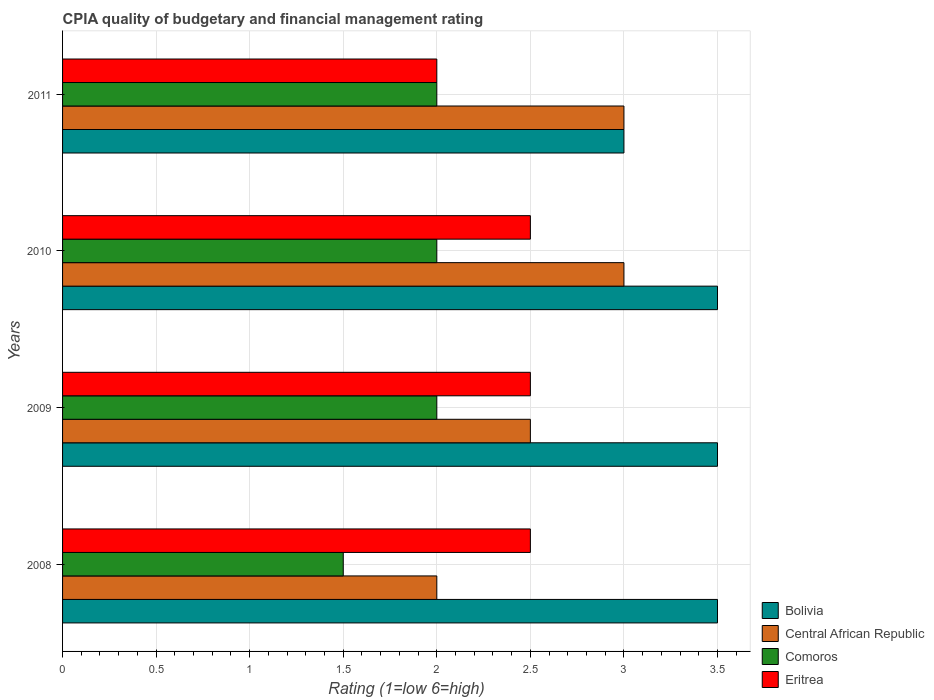How many different coloured bars are there?
Ensure brevity in your answer.  4. Are the number of bars on each tick of the Y-axis equal?
Offer a terse response. Yes. How many bars are there on the 4th tick from the top?
Your answer should be very brief. 4. What is the CPIA rating in Comoros in 2011?
Provide a succinct answer. 2. Across all years, what is the minimum CPIA rating in Eritrea?
Ensure brevity in your answer.  2. What is the average CPIA rating in Eritrea per year?
Give a very brief answer. 2.38. What is the ratio of the CPIA rating in Bolivia in 2008 to that in 2011?
Make the answer very short. 1.17. In how many years, is the CPIA rating in Comoros greater than the average CPIA rating in Comoros taken over all years?
Your response must be concise. 3. Is the sum of the CPIA rating in Central African Republic in 2009 and 2010 greater than the maximum CPIA rating in Bolivia across all years?
Ensure brevity in your answer.  Yes. Is it the case that in every year, the sum of the CPIA rating in Central African Republic and CPIA rating in Comoros is greater than the sum of CPIA rating in Eritrea and CPIA rating in Bolivia?
Your answer should be very brief. No. What does the 3rd bar from the top in 2010 represents?
Your answer should be very brief. Central African Republic. What does the 2nd bar from the bottom in 2008 represents?
Offer a very short reply. Central African Republic. Is it the case that in every year, the sum of the CPIA rating in Eritrea and CPIA rating in Comoros is greater than the CPIA rating in Central African Republic?
Give a very brief answer. Yes. How many bars are there?
Offer a terse response. 16. Are all the bars in the graph horizontal?
Your response must be concise. Yes. How many years are there in the graph?
Your answer should be compact. 4. Are the values on the major ticks of X-axis written in scientific E-notation?
Your response must be concise. No. Does the graph contain grids?
Offer a terse response. Yes. What is the title of the graph?
Offer a terse response. CPIA quality of budgetary and financial management rating. Does "Ecuador" appear as one of the legend labels in the graph?
Offer a very short reply. No. What is the label or title of the X-axis?
Provide a short and direct response. Rating (1=low 6=high). What is the Rating (1=low 6=high) in Comoros in 2008?
Provide a short and direct response. 1.5. What is the Rating (1=low 6=high) in Eritrea in 2008?
Your response must be concise. 2.5. What is the Rating (1=low 6=high) of Bolivia in 2009?
Make the answer very short. 3.5. What is the Rating (1=low 6=high) of Eritrea in 2009?
Provide a short and direct response. 2.5. What is the Rating (1=low 6=high) of Bolivia in 2010?
Make the answer very short. 3.5. What is the Rating (1=low 6=high) of Comoros in 2010?
Your response must be concise. 2. What is the Rating (1=low 6=high) in Bolivia in 2011?
Give a very brief answer. 3. What is the Rating (1=low 6=high) of Eritrea in 2011?
Keep it short and to the point. 2. Across all years, what is the maximum Rating (1=low 6=high) in Comoros?
Provide a succinct answer. 2. Across all years, what is the maximum Rating (1=low 6=high) in Eritrea?
Offer a terse response. 2.5. Across all years, what is the minimum Rating (1=low 6=high) in Central African Republic?
Ensure brevity in your answer.  2. Across all years, what is the minimum Rating (1=low 6=high) of Comoros?
Your response must be concise. 1.5. What is the total Rating (1=low 6=high) in Comoros in the graph?
Your answer should be very brief. 7.5. What is the difference between the Rating (1=low 6=high) in Bolivia in 2008 and that in 2010?
Provide a succinct answer. 0. What is the difference between the Rating (1=low 6=high) in Central African Republic in 2008 and that in 2010?
Give a very brief answer. -1. What is the difference between the Rating (1=low 6=high) of Bolivia in 2008 and that in 2011?
Keep it short and to the point. 0.5. What is the difference between the Rating (1=low 6=high) of Comoros in 2008 and that in 2011?
Keep it short and to the point. -0.5. What is the difference between the Rating (1=low 6=high) in Eritrea in 2008 and that in 2011?
Ensure brevity in your answer.  0.5. What is the difference between the Rating (1=low 6=high) of Eritrea in 2009 and that in 2010?
Give a very brief answer. 0. What is the difference between the Rating (1=low 6=high) in Bolivia in 2009 and that in 2011?
Provide a succinct answer. 0.5. What is the difference between the Rating (1=low 6=high) in Bolivia in 2010 and that in 2011?
Give a very brief answer. 0.5. What is the difference between the Rating (1=low 6=high) in Comoros in 2010 and that in 2011?
Your answer should be very brief. 0. What is the difference between the Rating (1=low 6=high) in Eritrea in 2010 and that in 2011?
Ensure brevity in your answer.  0.5. What is the difference between the Rating (1=low 6=high) of Bolivia in 2008 and the Rating (1=low 6=high) of Comoros in 2009?
Offer a very short reply. 1.5. What is the difference between the Rating (1=low 6=high) of Bolivia in 2008 and the Rating (1=low 6=high) of Eritrea in 2009?
Your answer should be compact. 1. What is the difference between the Rating (1=low 6=high) of Central African Republic in 2008 and the Rating (1=low 6=high) of Comoros in 2009?
Give a very brief answer. 0. What is the difference between the Rating (1=low 6=high) of Central African Republic in 2008 and the Rating (1=low 6=high) of Eritrea in 2009?
Offer a terse response. -0.5. What is the difference between the Rating (1=low 6=high) in Comoros in 2008 and the Rating (1=low 6=high) in Eritrea in 2009?
Ensure brevity in your answer.  -1. What is the difference between the Rating (1=low 6=high) of Bolivia in 2008 and the Rating (1=low 6=high) of Comoros in 2010?
Provide a short and direct response. 1.5. What is the difference between the Rating (1=low 6=high) in Central African Republic in 2008 and the Rating (1=low 6=high) in Comoros in 2010?
Your answer should be compact. 0. What is the difference between the Rating (1=low 6=high) of Comoros in 2008 and the Rating (1=low 6=high) of Eritrea in 2011?
Provide a succinct answer. -0.5. What is the difference between the Rating (1=low 6=high) of Bolivia in 2009 and the Rating (1=low 6=high) of Eritrea in 2010?
Keep it short and to the point. 1. What is the difference between the Rating (1=low 6=high) in Central African Republic in 2009 and the Rating (1=low 6=high) in Comoros in 2010?
Offer a terse response. 0.5. What is the difference between the Rating (1=low 6=high) in Comoros in 2009 and the Rating (1=low 6=high) in Eritrea in 2010?
Your response must be concise. -0.5. What is the difference between the Rating (1=low 6=high) of Bolivia in 2010 and the Rating (1=low 6=high) of Comoros in 2011?
Your answer should be compact. 1.5. What is the difference between the Rating (1=low 6=high) of Bolivia in 2010 and the Rating (1=low 6=high) of Eritrea in 2011?
Provide a short and direct response. 1.5. What is the difference between the Rating (1=low 6=high) in Central African Republic in 2010 and the Rating (1=low 6=high) in Comoros in 2011?
Ensure brevity in your answer.  1. What is the average Rating (1=low 6=high) in Bolivia per year?
Offer a very short reply. 3.38. What is the average Rating (1=low 6=high) of Central African Republic per year?
Make the answer very short. 2.62. What is the average Rating (1=low 6=high) of Comoros per year?
Provide a short and direct response. 1.88. What is the average Rating (1=low 6=high) in Eritrea per year?
Ensure brevity in your answer.  2.38. In the year 2008, what is the difference between the Rating (1=low 6=high) of Bolivia and Rating (1=low 6=high) of Central African Republic?
Provide a short and direct response. 1.5. In the year 2008, what is the difference between the Rating (1=low 6=high) of Bolivia and Rating (1=low 6=high) of Comoros?
Your answer should be compact. 2. In the year 2008, what is the difference between the Rating (1=low 6=high) of Central African Republic and Rating (1=low 6=high) of Comoros?
Your answer should be very brief. 0.5. In the year 2009, what is the difference between the Rating (1=low 6=high) of Bolivia and Rating (1=low 6=high) of Comoros?
Make the answer very short. 1.5. In the year 2009, what is the difference between the Rating (1=low 6=high) in Central African Republic and Rating (1=low 6=high) in Comoros?
Your answer should be compact. 0.5. In the year 2009, what is the difference between the Rating (1=low 6=high) of Central African Republic and Rating (1=low 6=high) of Eritrea?
Give a very brief answer. 0. In the year 2010, what is the difference between the Rating (1=low 6=high) in Bolivia and Rating (1=low 6=high) in Eritrea?
Give a very brief answer. 1. In the year 2010, what is the difference between the Rating (1=low 6=high) of Central African Republic and Rating (1=low 6=high) of Comoros?
Your response must be concise. 1. In the year 2011, what is the difference between the Rating (1=low 6=high) of Bolivia and Rating (1=low 6=high) of Eritrea?
Your answer should be compact. 1. In the year 2011, what is the difference between the Rating (1=low 6=high) of Comoros and Rating (1=low 6=high) of Eritrea?
Provide a succinct answer. 0. What is the ratio of the Rating (1=low 6=high) of Central African Republic in 2008 to that in 2009?
Ensure brevity in your answer.  0.8. What is the ratio of the Rating (1=low 6=high) in Bolivia in 2008 to that in 2010?
Give a very brief answer. 1. What is the ratio of the Rating (1=low 6=high) of Comoros in 2008 to that in 2010?
Your response must be concise. 0.75. What is the ratio of the Rating (1=low 6=high) in Eritrea in 2008 to that in 2010?
Give a very brief answer. 1. What is the ratio of the Rating (1=low 6=high) of Comoros in 2008 to that in 2011?
Offer a terse response. 0.75. What is the ratio of the Rating (1=low 6=high) in Eritrea in 2008 to that in 2011?
Your answer should be very brief. 1.25. What is the ratio of the Rating (1=low 6=high) of Bolivia in 2009 to that in 2010?
Make the answer very short. 1. What is the ratio of the Rating (1=low 6=high) of Central African Republic in 2009 to that in 2010?
Provide a succinct answer. 0.83. What is the ratio of the Rating (1=low 6=high) in Bolivia in 2009 to that in 2011?
Keep it short and to the point. 1.17. What is the ratio of the Rating (1=low 6=high) of Eritrea in 2009 to that in 2011?
Offer a terse response. 1.25. What is the ratio of the Rating (1=low 6=high) of Central African Republic in 2010 to that in 2011?
Ensure brevity in your answer.  1. What is the difference between the highest and the second highest Rating (1=low 6=high) of Comoros?
Provide a succinct answer. 0. What is the difference between the highest and the second highest Rating (1=low 6=high) of Eritrea?
Ensure brevity in your answer.  0. What is the difference between the highest and the lowest Rating (1=low 6=high) in Bolivia?
Offer a terse response. 0.5. What is the difference between the highest and the lowest Rating (1=low 6=high) in Comoros?
Ensure brevity in your answer.  0.5. 